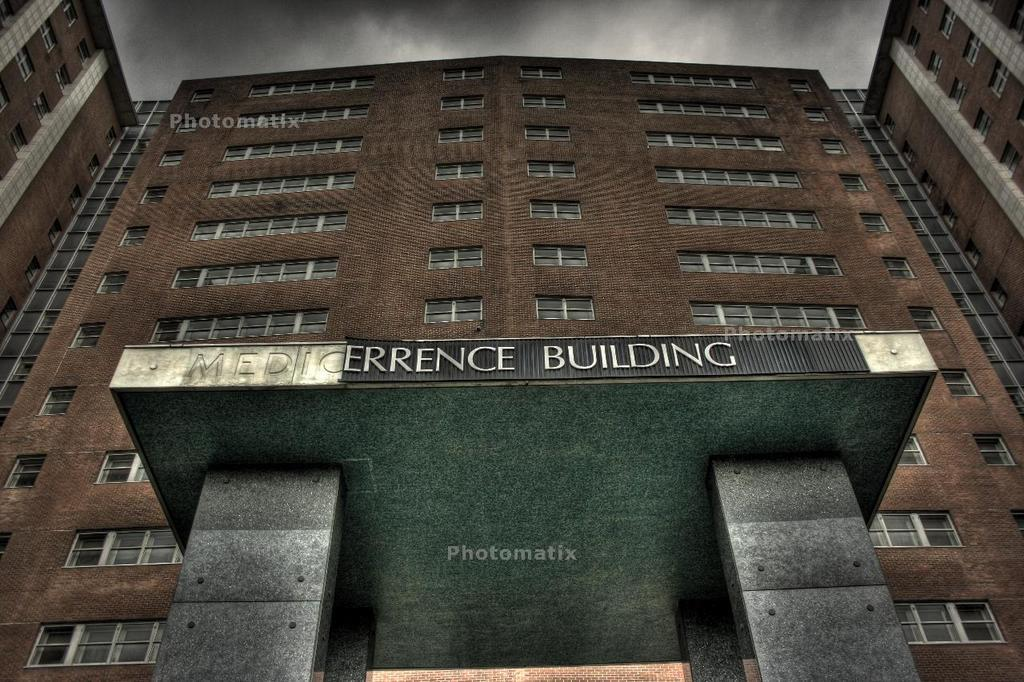What type of structure is in the image? There is a building in the image. What features can be seen on the building? The building has windows and pillars. Is there any text on the building? Yes, there is text on the building. What can be seen in the sky in the image? The sky is visible in the image, and there are clouds in the sky. What type of light is being used to stitch the question onto the building? There is no light or stitching present in the image; the text on the building is likely printed or painted. 